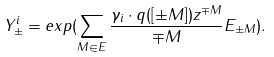<formula> <loc_0><loc_0><loc_500><loc_500>Y _ { \pm } ^ { i } = e x p ( \sum _ { M \in E } \frac { \gamma _ { i } \cdot q ( [ \pm M ] ) z ^ { \mp M } } { \mp M } E _ { \pm M } ) .</formula> 